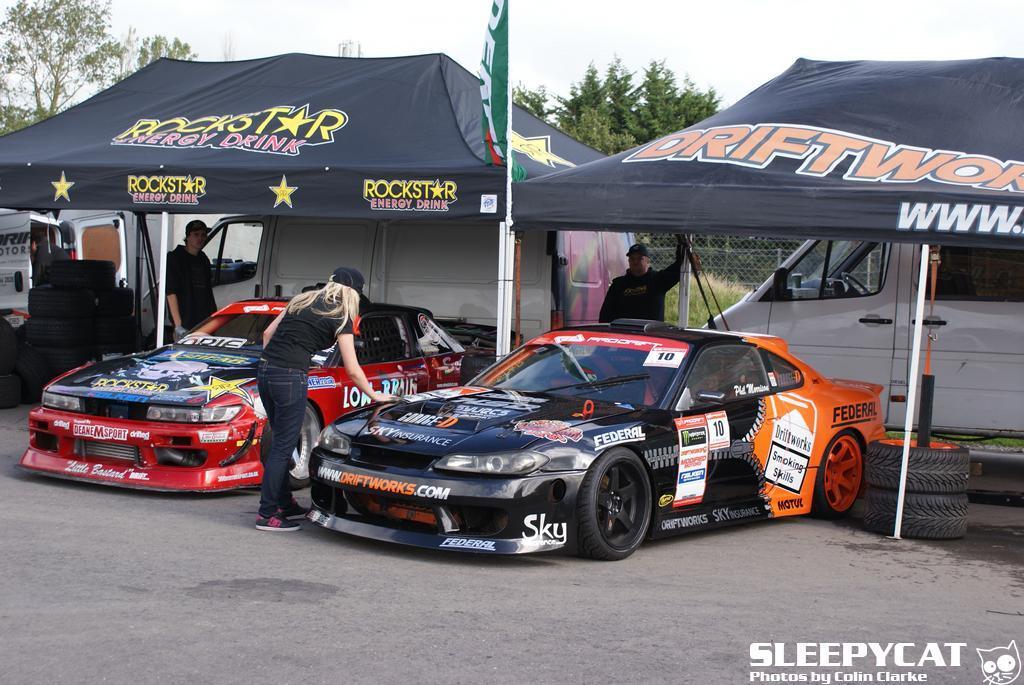Could you give a brief overview of what you see in this image? In this picture we can see two cars and two tents, there are three persons standing, in the background there are some trees, we can see vehicles and tyres here, there is the sky at the top of the picture, we can see a fencing here, at the right bottom there is some text. 